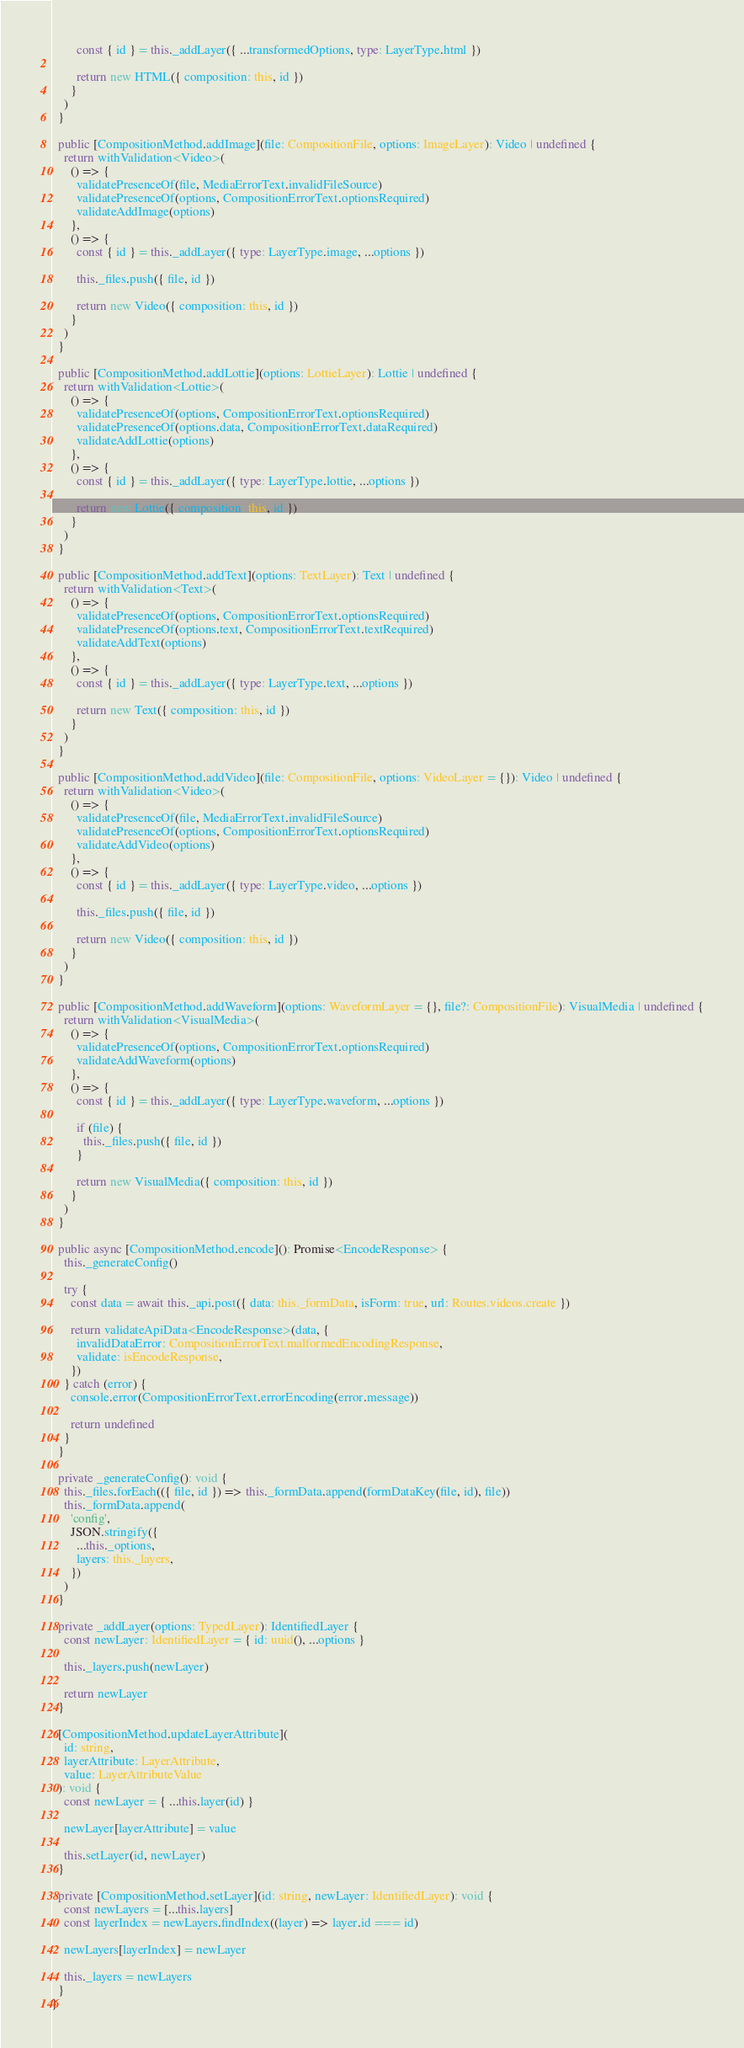<code> <loc_0><loc_0><loc_500><loc_500><_TypeScript_>
        const { id } = this._addLayer({ ...transformedOptions, type: LayerType.html })

        return new HTML({ composition: this, id })
      }
    )
  }

  public [CompositionMethod.addImage](file: CompositionFile, options: ImageLayer): Video | undefined {
    return withValidation<Video>(
      () => {
        validatePresenceOf(file, MediaErrorText.invalidFileSource)
        validatePresenceOf(options, CompositionErrorText.optionsRequired)
        validateAddImage(options)
      },
      () => {
        const { id } = this._addLayer({ type: LayerType.image, ...options })

        this._files.push({ file, id })

        return new Video({ composition: this, id })
      }
    )
  }

  public [CompositionMethod.addLottie](options: LottieLayer): Lottie | undefined {
    return withValidation<Lottie>(
      () => {
        validatePresenceOf(options, CompositionErrorText.optionsRequired)
        validatePresenceOf(options.data, CompositionErrorText.dataRequired)
        validateAddLottie(options)
      },
      () => {
        const { id } = this._addLayer({ type: LayerType.lottie, ...options })

        return new Lottie({ composition: this, id })
      }
    )
  }

  public [CompositionMethod.addText](options: TextLayer): Text | undefined {
    return withValidation<Text>(
      () => {
        validatePresenceOf(options, CompositionErrorText.optionsRequired)
        validatePresenceOf(options.text, CompositionErrorText.textRequired)
        validateAddText(options)
      },
      () => {
        const { id } = this._addLayer({ type: LayerType.text, ...options })

        return new Text({ composition: this, id })
      }
    )
  }

  public [CompositionMethod.addVideo](file: CompositionFile, options: VideoLayer = {}): Video | undefined {
    return withValidation<Video>(
      () => {
        validatePresenceOf(file, MediaErrorText.invalidFileSource)
        validatePresenceOf(options, CompositionErrorText.optionsRequired)
        validateAddVideo(options)
      },
      () => {
        const { id } = this._addLayer({ type: LayerType.video, ...options })

        this._files.push({ file, id })

        return new Video({ composition: this, id })
      }
    )
  }

  public [CompositionMethod.addWaveform](options: WaveformLayer = {}, file?: CompositionFile): VisualMedia | undefined {
    return withValidation<VisualMedia>(
      () => {
        validatePresenceOf(options, CompositionErrorText.optionsRequired)
        validateAddWaveform(options)
      },
      () => {
        const { id } = this._addLayer({ type: LayerType.waveform, ...options })

        if (file) {
          this._files.push({ file, id })
        }

        return new VisualMedia({ composition: this, id })
      }
    )
  }

  public async [CompositionMethod.encode](): Promise<EncodeResponse> {
    this._generateConfig()

    try {
      const data = await this._api.post({ data: this._formData, isForm: true, url: Routes.videos.create })

      return validateApiData<EncodeResponse>(data, {
        invalidDataError: CompositionErrorText.malformedEncodingResponse,
        validate: isEncodeResponse,
      })
    } catch (error) {
      console.error(CompositionErrorText.errorEncoding(error.message))

      return undefined
    }
  }

  private _generateConfig(): void {
    this._files.forEach(({ file, id }) => this._formData.append(formDataKey(file, id), file))
    this._formData.append(
      'config',
      JSON.stringify({
        ...this._options,
        layers: this._layers,
      })
    )
  }

  private _addLayer(options: TypedLayer): IdentifiedLayer {
    const newLayer: IdentifiedLayer = { id: uuid(), ...options }

    this._layers.push(newLayer)

    return newLayer
  }

  [CompositionMethod.updateLayerAttribute](
    id: string,
    layerAttribute: LayerAttribute,
    value: LayerAttributeValue
  ): void {
    const newLayer = { ...this.layer(id) }

    newLayer[layerAttribute] = value

    this.setLayer(id, newLayer)
  }

  private [CompositionMethod.setLayer](id: string, newLayer: IdentifiedLayer): void {
    const newLayers = [...this.layers]
    const layerIndex = newLayers.findIndex((layer) => layer.id === id)

    newLayers[layerIndex] = newLayer

    this._layers = newLayers
  }
}
</code> 